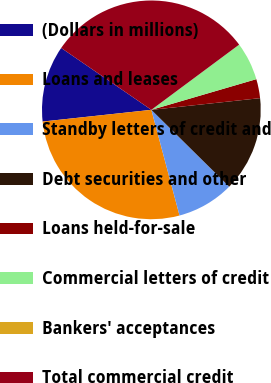Convert chart to OTSL. <chart><loc_0><loc_0><loc_500><loc_500><pie_chart><fcel>(Dollars in millions)<fcel>Loans and leases<fcel>Standby letters of credit and<fcel>Debt securities and other<fcel>Loans held-for-sale<fcel>Commercial letters of credit<fcel>Bankers' acceptances<fcel>Total commercial credit<nl><fcel>11.28%<fcel>27.44%<fcel>8.46%<fcel>14.1%<fcel>2.82%<fcel>5.64%<fcel>0.0%<fcel>30.26%<nl></chart> 